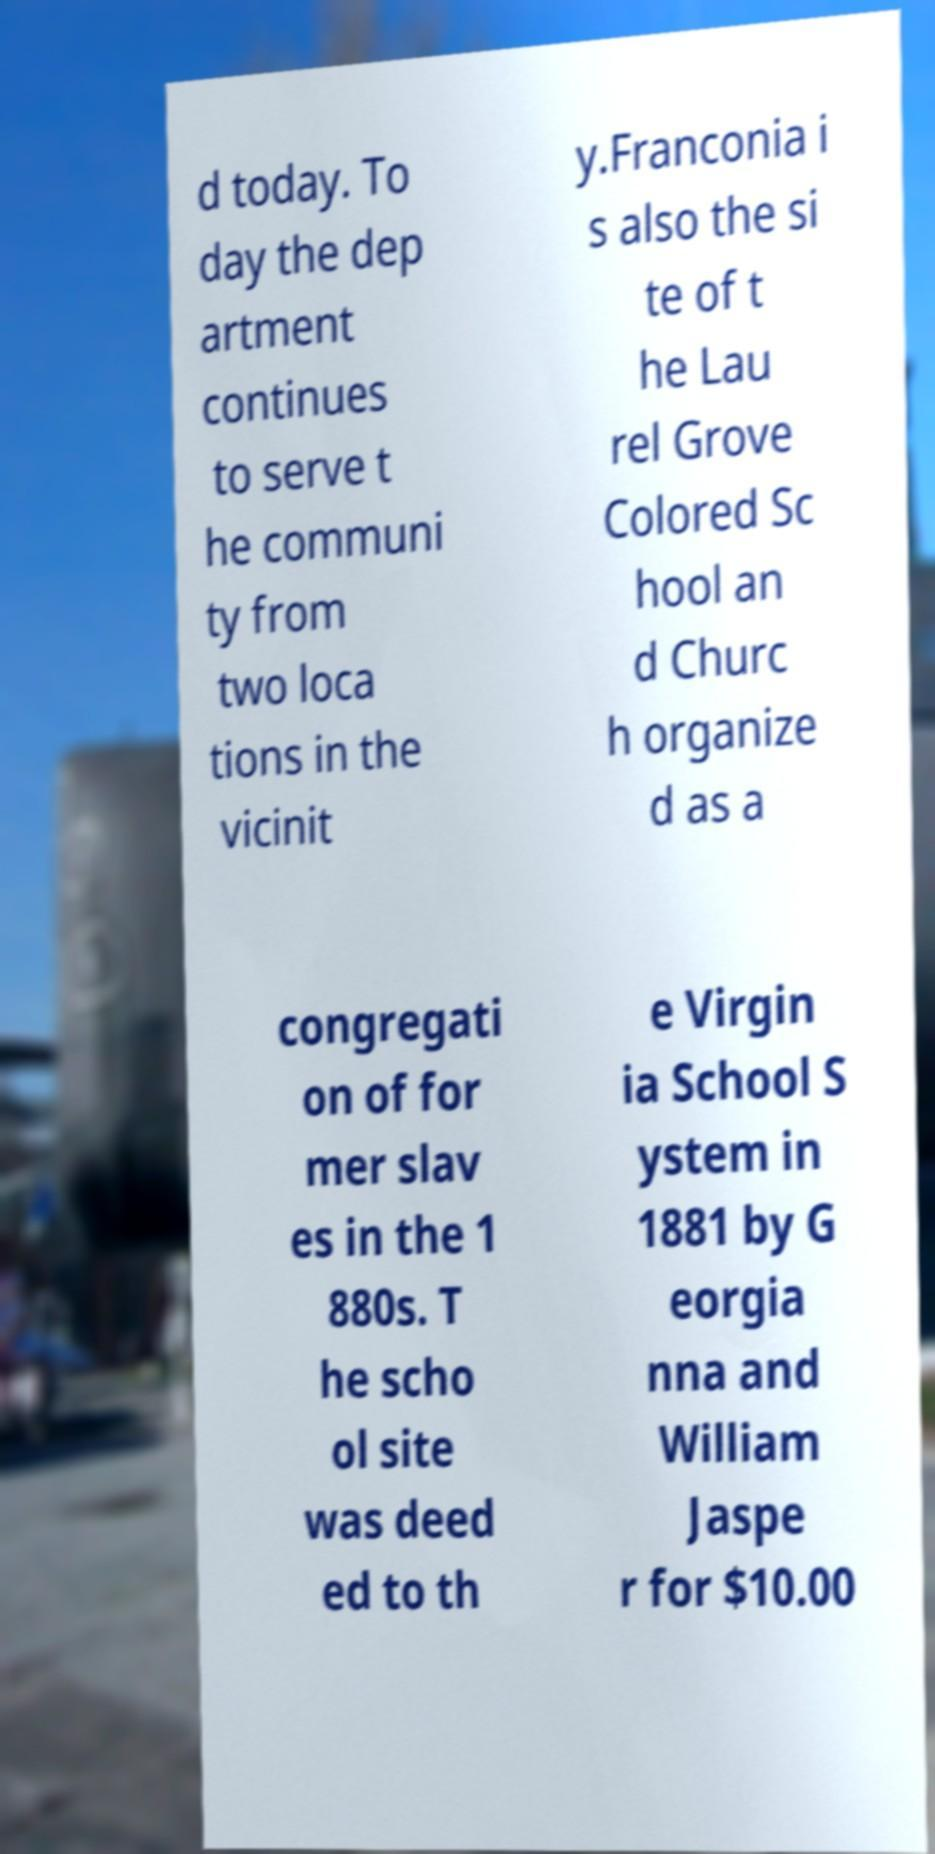I need the written content from this picture converted into text. Can you do that? d today. To day the dep artment continues to serve t he communi ty from two loca tions in the vicinit y.Franconia i s also the si te of t he Lau rel Grove Colored Sc hool an d Churc h organize d as a congregati on of for mer slav es in the 1 880s. T he scho ol site was deed ed to th e Virgin ia School S ystem in 1881 by G eorgia nna and William Jaspe r for $10.00 